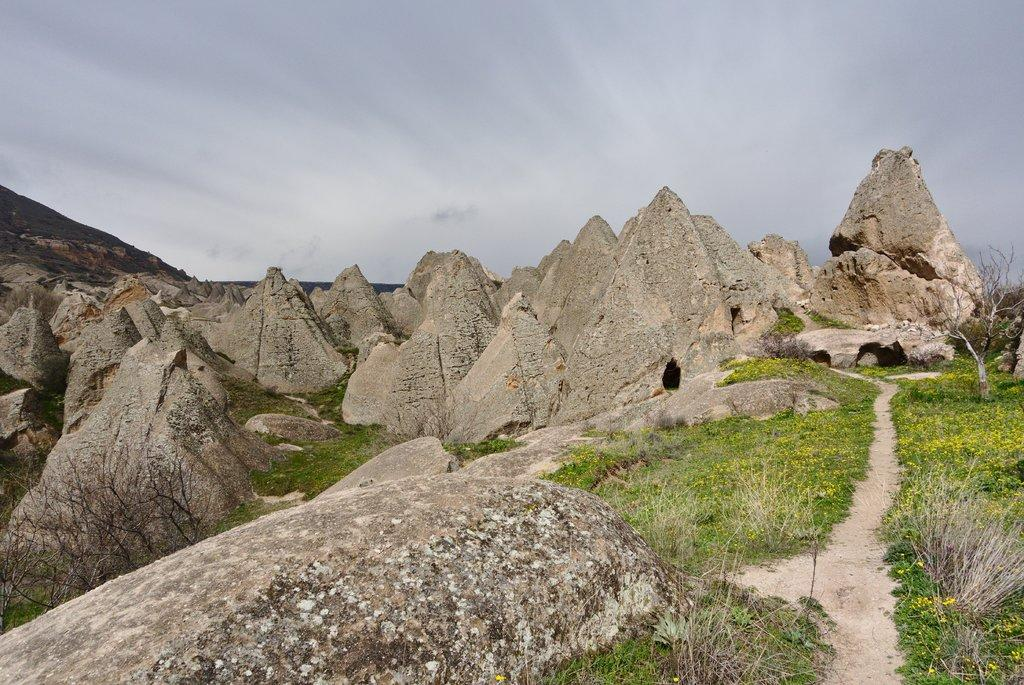What is the main subject in the center of the image? There are rocks in the center of the image. What type of vegetation is present at the bottom of the image? There is grass at the bottom of the image. What is visible at the top of the image? The sky is visible at the top of the image. What can be seen in the sky? Clouds are present in the sky. What route does the basketball take in the image? There is no basketball present in the image, so it is not possible to determine a route. 